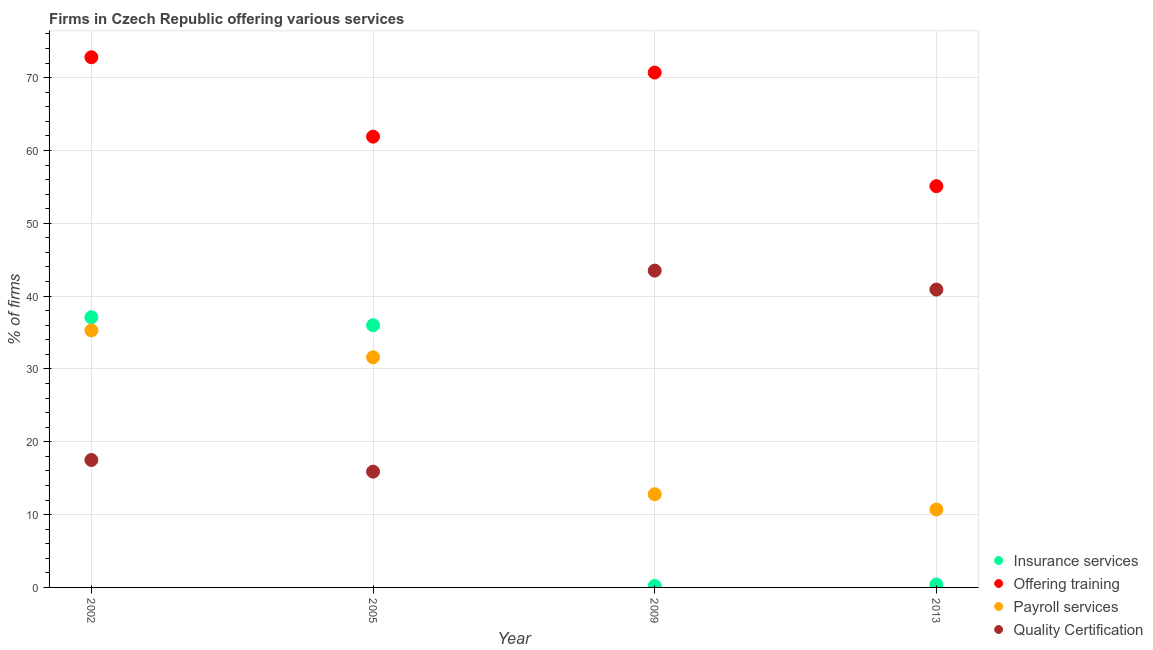How many different coloured dotlines are there?
Offer a terse response. 4. Across all years, what is the maximum percentage of firms offering payroll services?
Make the answer very short. 35.3. Across all years, what is the minimum percentage of firms offering payroll services?
Offer a terse response. 10.7. In which year was the percentage of firms offering payroll services maximum?
Provide a short and direct response. 2002. In which year was the percentage of firms offering training minimum?
Your answer should be very brief. 2013. What is the total percentage of firms offering quality certification in the graph?
Provide a short and direct response. 117.8. What is the difference between the percentage of firms offering insurance services in 2005 and that in 2013?
Offer a terse response. 35.6. What is the difference between the percentage of firms offering training in 2002 and the percentage of firms offering payroll services in 2005?
Offer a very short reply. 41.2. What is the average percentage of firms offering quality certification per year?
Give a very brief answer. 29.45. In the year 2005, what is the difference between the percentage of firms offering insurance services and percentage of firms offering training?
Give a very brief answer. -25.9. What is the ratio of the percentage of firms offering training in 2002 to that in 2013?
Make the answer very short. 1.32. Is the difference between the percentage of firms offering quality certification in 2002 and 2013 greater than the difference between the percentage of firms offering insurance services in 2002 and 2013?
Your answer should be compact. No. What is the difference between the highest and the second highest percentage of firms offering insurance services?
Make the answer very short. 1.1. What is the difference between the highest and the lowest percentage of firms offering insurance services?
Your answer should be compact. 36.9. In how many years, is the percentage of firms offering payroll services greater than the average percentage of firms offering payroll services taken over all years?
Provide a succinct answer. 2. Is it the case that in every year, the sum of the percentage of firms offering training and percentage of firms offering insurance services is greater than the sum of percentage of firms offering payroll services and percentage of firms offering quality certification?
Give a very brief answer. Yes. Is it the case that in every year, the sum of the percentage of firms offering insurance services and percentage of firms offering training is greater than the percentage of firms offering payroll services?
Ensure brevity in your answer.  Yes. Is the percentage of firms offering insurance services strictly less than the percentage of firms offering quality certification over the years?
Your answer should be very brief. No. How many years are there in the graph?
Offer a terse response. 4. Does the graph contain any zero values?
Your response must be concise. No. How many legend labels are there?
Your response must be concise. 4. How are the legend labels stacked?
Your response must be concise. Vertical. What is the title of the graph?
Provide a short and direct response. Firms in Czech Republic offering various services . What is the label or title of the Y-axis?
Provide a short and direct response. % of firms. What is the % of firms of Insurance services in 2002?
Provide a succinct answer. 37.1. What is the % of firms of Offering training in 2002?
Keep it short and to the point. 72.8. What is the % of firms of Payroll services in 2002?
Your answer should be compact. 35.3. What is the % of firms of Insurance services in 2005?
Your response must be concise. 36. What is the % of firms in Offering training in 2005?
Your answer should be very brief. 61.9. What is the % of firms in Payroll services in 2005?
Make the answer very short. 31.6. What is the % of firms in Quality Certification in 2005?
Provide a short and direct response. 15.9. What is the % of firms in Insurance services in 2009?
Your response must be concise. 0.2. What is the % of firms in Offering training in 2009?
Give a very brief answer. 70.7. What is the % of firms in Quality Certification in 2009?
Offer a terse response. 43.5. What is the % of firms of Offering training in 2013?
Keep it short and to the point. 55.1. What is the % of firms of Quality Certification in 2013?
Provide a short and direct response. 40.9. Across all years, what is the maximum % of firms of Insurance services?
Provide a succinct answer. 37.1. Across all years, what is the maximum % of firms of Offering training?
Ensure brevity in your answer.  72.8. Across all years, what is the maximum % of firms of Payroll services?
Ensure brevity in your answer.  35.3. Across all years, what is the maximum % of firms in Quality Certification?
Offer a very short reply. 43.5. Across all years, what is the minimum % of firms of Insurance services?
Your response must be concise. 0.2. Across all years, what is the minimum % of firms of Offering training?
Offer a very short reply. 55.1. Across all years, what is the minimum % of firms in Payroll services?
Offer a terse response. 10.7. Across all years, what is the minimum % of firms of Quality Certification?
Provide a succinct answer. 15.9. What is the total % of firms of Insurance services in the graph?
Keep it short and to the point. 73.7. What is the total % of firms in Offering training in the graph?
Keep it short and to the point. 260.5. What is the total % of firms of Payroll services in the graph?
Ensure brevity in your answer.  90.4. What is the total % of firms of Quality Certification in the graph?
Keep it short and to the point. 117.8. What is the difference between the % of firms in Payroll services in 2002 and that in 2005?
Your answer should be very brief. 3.7. What is the difference between the % of firms of Insurance services in 2002 and that in 2009?
Ensure brevity in your answer.  36.9. What is the difference between the % of firms of Insurance services in 2002 and that in 2013?
Make the answer very short. 36.7. What is the difference between the % of firms of Payroll services in 2002 and that in 2013?
Your answer should be very brief. 24.6. What is the difference between the % of firms in Quality Certification in 2002 and that in 2013?
Your answer should be very brief. -23.4. What is the difference between the % of firms in Insurance services in 2005 and that in 2009?
Keep it short and to the point. 35.8. What is the difference between the % of firms in Offering training in 2005 and that in 2009?
Keep it short and to the point. -8.8. What is the difference between the % of firms of Payroll services in 2005 and that in 2009?
Offer a very short reply. 18.8. What is the difference between the % of firms of Quality Certification in 2005 and that in 2009?
Your response must be concise. -27.6. What is the difference between the % of firms of Insurance services in 2005 and that in 2013?
Keep it short and to the point. 35.6. What is the difference between the % of firms of Payroll services in 2005 and that in 2013?
Ensure brevity in your answer.  20.9. What is the difference between the % of firms in Quality Certification in 2005 and that in 2013?
Make the answer very short. -25. What is the difference between the % of firms in Offering training in 2009 and that in 2013?
Provide a succinct answer. 15.6. What is the difference between the % of firms of Payroll services in 2009 and that in 2013?
Give a very brief answer. 2.1. What is the difference between the % of firms in Insurance services in 2002 and the % of firms in Offering training in 2005?
Give a very brief answer. -24.8. What is the difference between the % of firms of Insurance services in 2002 and the % of firms of Quality Certification in 2005?
Provide a succinct answer. 21.2. What is the difference between the % of firms of Offering training in 2002 and the % of firms of Payroll services in 2005?
Your answer should be compact. 41.2. What is the difference between the % of firms of Offering training in 2002 and the % of firms of Quality Certification in 2005?
Ensure brevity in your answer.  56.9. What is the difference between the % of firms in Insurance services in 2002 and the % of firms in Offering training in 2009?
Your response must be concise. -33.6. What is the difference between the % of firms of Insurance services in 2002 and the % of firms of Payroll services in 2009?
Provide a succinct answer. 24.3. What is the difference between the % of firms in Offering training in 2002 and the % of firms in Quality Certification in 2009?
Provide a short and direct response. 29.3. What is the difference between the % of firms of Insurance services in 2002 and the % of firms of Offering training in 2013?
Make the answer very short. -18. What is the difference between the % of firms of Insurance services in 2002 and the % of firms of Payroll services in 2013?
Offer a very short reply. 26.4. What is the difference between the % of firms of Offering training in 2002 and the % of firms of Payroll services in 2013?
Ensure brevity in your answer.  62.1. What is the difference between the % of firms in Offering training in 2002 and the % of firms in Quality Certification in 2013?
Provide a short and direct response. 31.9. What is the difference between the % of firms of Payroll services in 2002 and the % of firms of Quality Certification in 2013?
Make the answer very short. -5.6. What is the difference between the % of firms in Insurance services in 2005 and the % of firms in Offering training in 2009?
Offer a very short reply. -34.7. What is the difference between the % of firms in Insurance services in 2005 and the % of firms in Payroll services in 2009?
Provide a short and direct response. 23.2. What is the difference between the % of firms in Insurance services in 2005 and the % of firms in Quality Certification in 2009?
Provide a short and direct response. -7.5. What is the difference between the % of firms of Offering training in 2005 and the % of firms of Payroll services in 2009?
Your answer should be compact. 49.1. What is the difference between the % of firms in Insurance services in 2005 and the % of firms in Offering training in 2013?
Provide a short and direct response. -19.1. What is the difference between the % of firms in Insurance services in 2005 and the % of firms in Payroll services in 2013?
Provide a short and direct response. 25.3. What is the difference between the % of firms in Offering training in 2005 and the % of firms in Payroll services in 2013?
Make the answer very short. 51.2. What is the difference between the % of firms in Offering training in 2005 and the % of firms in Quality Certification in 2013?
Your answer should be very brief. 21. What is the difference between the % of firms in Payroll services in 2005 and the % of firms in Quality Certification in 2013?
Give a very brief answer. -9.3. What is the difference between the % of firms in Insurance services in 2009 and the % of firms in Offering training in 2013?
Provide a succinct answer. -54.9. What is the difference between the % of firms in Insurance services in 2009 and the % of firms in Payroll services in 2013?
Make the answer very short. -10.5. What is the difference between the % of firms of Insurance services in 2009 and the % of firms of Quality Certification in 2013?
Your answer should be very brief. -40.7. What is the difference between the % of firms of Offering training in 2009 and the % of firms of Payroll services in 2013?
Give a very brief answer. 60. What is the difference between the % of firms of Offering training in 2009 and the % of firms of Quality Certification in 2013?
Offer a terse response. 29.8. What is the difference between the % of firms of Payroll services in 2009 and the % of firms of Quality Certification in 2013?
Offer a very short reply. -28.1. What is the average % of firms of Insurance services per year?
Keep it short and to the point. 18.43. What is the average % of firms in Offering training per year?
Ensure brevity in your answer.  65.12. What is the average % of firms in Payroll services per year?
Ensure brevity in your answer.  22.6. What is the average % of firms of Quality Certification per year?
Ensure brevity in your answer.  29.45. In the year 2002, what is the difference between the % of firms of Insurance services and % of firms of Offering training?
Make the answer very short. -35.7. In the year 2002, what is the difference between the % of firms in Insurance services and % of firms in Payroll services?
Provide a succinct answer. 1.8. In the year 2002, what is the difference between the % of firms of Insurance services and % of firms of Quality Certification?
Keep it short and to the point. 19.6. In the year 2002, what is the difference between the % of firms in Offering training and % of firms in Payroll services?
Offer a terse response. 37.5. In the year 2002, what is the difference between the % of firms in Offering training and % of firms in Quality Certification?
Ensure brevity in your answer.  55.3. In the year 2002, what is the difference between the % of firms in Payroll services and % of firms in Quality Certification?
Your answer should be compact. 17.8. In the year 2005, what is the difference between the % of firms in Insurance services and % of firms in Offering training?
Your answer should be very brief. -25.9. In the year 2005, what is the difference between the % of firms of Insurance services and % of firms of Payroll services?
Provide a succinct answer. 4.4. In the year 2005, what is the difference between the % of firms of Insurance services and % of firms of Quality Certification?
Make the answer very short. 20.1. In the year 2005, what is the difference between the % of firms of Offering training and % of firms of Payroll services?
Keep it short and to the point. 30.3. In the year 2005, what is the difference between the % of firms in Payroll services and % of firms in Quality Certification?
Provide a short and direct response. 15.7. In the year 2009, what is the difference between the % of firms of Insurance services and % of firms of Offering training?
Keep it short and to the point. -70.5. In the year 2009, what is the difference between the % of firms of Insurance services and % of firms of Payroll services?
Keep it short and to the point. -12.6. In the year 2009, what is the difference between the % of firms in Insurance services and % of firms in Quality Certification?
Your answer should be very brief. -43.3. In the year 2009, what is the difference between the % of firms of Offering training and % of firms of Payroll services?
Offer a terse response. 57.9. In the year 2009, what is the difference between the % of firms in Offering training and % of firms in Quality Certification?
Your answer should be very brief. 27.2. In the year 2009, what is the difference between the % of firms of Payroll services and % of firms of Quality Certification?
Your answer should be compact. -30.7. In the year 2013, what is the difference between the % of firms in Insurance services and % of firms in Offering training?
Make the answer very short. -54.7. In the year 2013, what is the difference between the % of firms in Insurance services and % of firms in Payroll services?
Give a very brief answer. -10.3. In the year 2013, what is the difference between the % of firms in Insurance services and % of firms in Quality Certification?
Your answer should be compact. -40.5. In the year 2013, what is the difference between the % of firms in Offering training and % of firms in Payroll services?
Ensure brevity in your answer.  44.4. In the year 2013, what is the difference between the % of firms of Offering training and % of firms of Quality Certification?
Provide a succinct answer. 14.2. In the year 2013, what is the difference between the % of firms of Payroll services and % of firms of Quality Certification?
Ensure brevity in your answer.  -30.2. What is the ratio of the % of firms in Insurance services in 2002 to that in 2005?
Provide a short and direct response. 1.03. What is the ratio of the % of firms in Offering training in 2002 to that in 2005?
Your answer should be very brief. 1.18. What is the ratio of the % of firms of Payroll services in 2002 to that in 2005?
Provide a short and direct response. 1.12. What is the ratio of the % of firms of Quality Certification in 2002 to that in 2005?
Your answer should be compact. 1.1. What is the ratio of the % of firms of Insurance services in 2002 to that in 2009?
Offer a very short reply. 185.5. What is the ratio of the % of firms in Offering training in 2002 to that in 2009?
Give a very brief answer. 1.03. What is the ratio of the % of firms of Payroll services in 2002 to that in 2009?
Offer a very short reply. 2.76. What is the ratio of the % of firms of Quality Certification in 2002 to that in 2009?
Your answer should be compact. 0.4. What is the ratio of the % of firms in Insurance services in 2002 to that in 2013?
Ensure brevity in your answer.  92.75. What is the ratio of the % of firms of Offering training in 2002 to that in 2013?
Your answer should be very brief. 1.32. What is the ratio of the % of firms in Payroll services in 2002 to that in 2013?
Offer a very short reply. 3.3. What is the ratio of the % of firms of Quality Certification in 2002 to that in 2013?
Ensure brevity in your answer.  0.43. What is the ratio of the % of firms of Insurance services in 2005 to that in 2009?
Give a very brief answer. 180. What is the ratio of the % of firms of Offering training in 2005 to that in 2009?
Provide a succinct answer. 0.88. What is the ratio of the % of firms in Payroll services in 2005 to that in 2009?
Your answer should be compact. 2.47. What is the ratio of the % of firms in Quality Certification in 2005 to that in 2009?
Offer a very short reply. 0.37. What is the ratio of the % of firms in Insurance services in 2005 to that in 2013?
Provide a succinct answer. 90. What is the ratio of the % of firms in Offering training in 2005 to that in 2013?
Make the answer very short. 1.12. What is the ratio of the % of firms of Payroll services in 2005 to that in 2013?
Provide a short and direct response. 2.95. What is the ratio of the % of firms in Quality Certification in 2005 to that in 2013?
Ensure brevity in your answer.  0.39. What is the ratio of the % of firms in Offering training in 2009 to that in 2013?
Keep it short and to the point. 1.28. What is the ratio of the % of firms in Payroll services in 2009 to that in 2013?
Your answer should be compact. 1.2. What is the ratio of the % of firms in Quality Certification in 2009 to that in 2013?
Offer a very short reply. 1.06. What is the difference between the highest and the second highest % of firms in Insurance services?
Your answer should be compact. 1.1. What is the difference between the highest and the second highest % of firms of Offering training?
Offer a terse response. 2.1. What is the difference between the highest and the second highest % of firms of Quality Certification?
Provide a succinct answer. 2.6. What is the difference between the highest and the lowest % of firms in Insurance services?
Offer a very short reply. 36.9. What is the difference between the highest and the lowest % of firms in Payroll services?
Give a very brief answer. 24.6. What is the difference between the highest and the lowest % of firms in Quality Certification?
Provide a succinct answer. 27.6. 